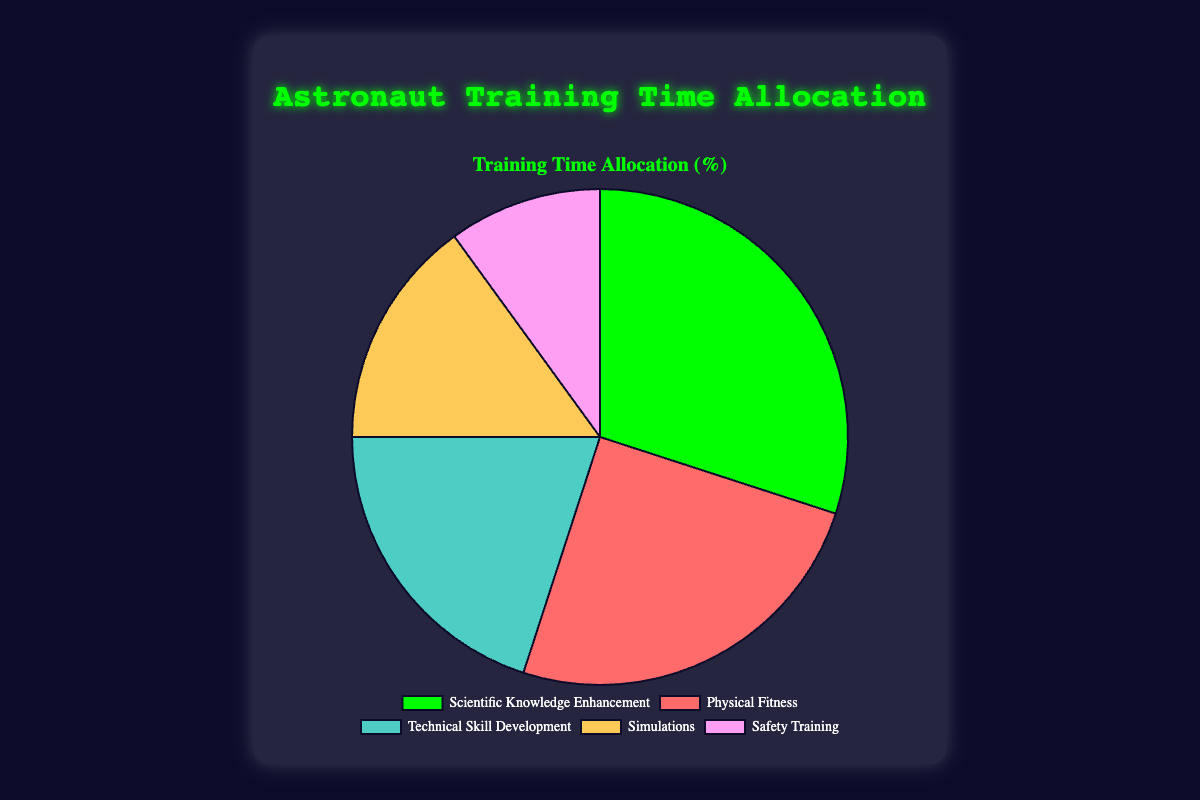Is more time allocated to Physical Fitness or Technical Skill Development? The pie chart shows that Physical Fitness has 25% time allocation, while Technical Skill Development has 20%. 25% is greater than 20%.
Answer: Physical Fitness What is the combined percentage allocation for Safety Training and Simulations? Safety Training allocates 10% and Simulations allocate 15%. Adding these gives 10% + 15% = 25%.
Answer: 25% Which category has the highest time allocation? The category with the highest percentage slice in the pie chart is Scientific Knowledge Enhancement with 30%.
Answer: Scientific Knowledge Enhancement How does the time allocated to Scientific Knowledge Enhancement compare to the total time allocated to Safety Training and Simulations combined? Scientific Knowledge Enhancement is 30%, while Safety Training and Simulations combined is 25% (10% + 15%). 30% is greater than 25%.
Answer: Greater If you combine the percentages for Physical Fitness and Technical Skill Development, how much more is it compared to the time allocated for Simulations? Physical Fitness plus Technical Skill Development is 25% + 20% = 45%. The difference with Simulations, which is 15%, is 45% - 15% = 30%.
Answer: 30% What percentage of the training time is NOT allocated to Scientific Knowledge Enhancement? Scientific Knowledge Enhancement takes up 30%, so the remaining percentage is 100% - 30% = 70%.
Answer: 70% Which category has the smallest allocation and what is it? The smallest slice in the pie chart represents Safety Training, which has a 10% allocation.
Answer: Safety Training, 10% By how much does the allocation for Scientific Knowledge Enhancement exceed the allocation for Technical Skill Development? The allocation for Scientific Knowledge Enhancement is 30%, and for Technical Skill Development, it is 20%. The difference is 30% - 20% = 10%.
Answer: 10% What is the average percentage time allocation of all the training categories shown? Sum of all percentages is 25% + 20% + 15% + 10% + 30% = 100%. Dividing by 5 categories gives 100% / 5 = 20%.
Answer: 20% What color represents the Simulations category in the pie chart? The color associated with Simulations in the pie chart is yellow.
Answer: Yellow 